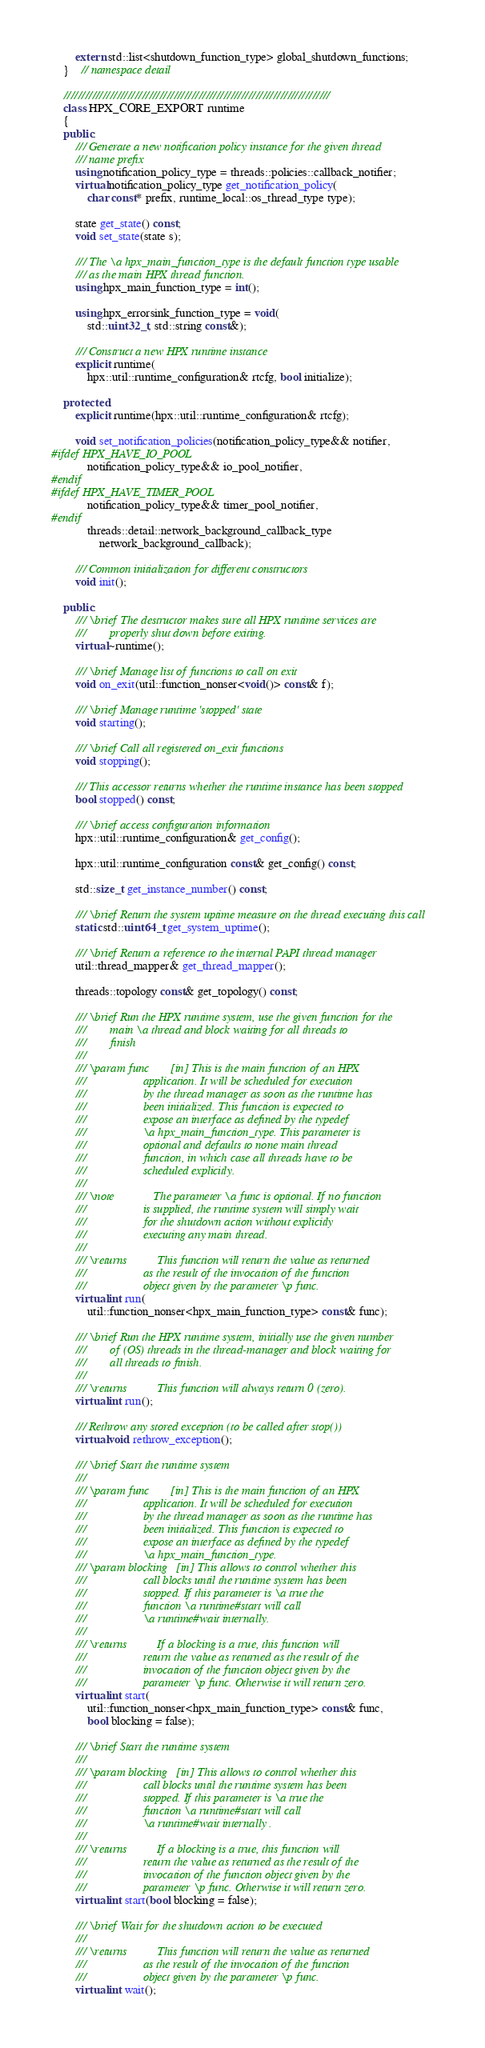Convert code to text. <code><loc_0><loc_0><loc_500><loc_500><_C++_>        extern std::list<shutdown_function_type> global_shutdown_functions;
    }    // namespace detail

    ///////////////////////////////////////////////////////////////////////////
    class HPX_CORE_EXPORT runtime
    {
    public:
        /// Generate a new notification policy instance for the given thread
        /// name prefix
        using notification_policy_type = threads::policies::callback_notifier;
        virtual notification_policy_type get_notification_policy(
            char const* prefix, runtime_local::os_thread_type type);

        state get_state() const;
        void set_state(state s);

        /// The \a hpx_main_function_type is the default function type usable
        /// as the main HPX thread function.
        using hpx_main_function_type = int();

        using hpx_errorsink_function_type = void(
            std::uint32_t, std::string const&);

        /// Construct a new HPX runtime instance
        explicit runtime(
            hpx::util::runtime_configuration& rtcfg, bool initialize);

    protected:
        explicit runtime(hpx::util::runtime_configuration& rtcfg);

        void set_notification_policies(notification_policy_type&& notifier,
#ifdef HPX_HAVE_IO_POOL
            notification_policy_type&& io_pool_notifier,
#endif
#ifdef HPX_HAVE_TIMER_POOL
            notification_policy_type&& timer_pool_notifier,
#endif
            threads::detail::network_background_callback_type
                network_background_callback);

        /// Common initialization for different constructors
        void init();

    public:
        /// \brief The destructor makes sure all HPX runtime services are
        ///        properly shut down before exiting.
        virtual ~runtime();

        /// \brief Manage list of functions to call on exit
        void on_exit(util::function_nonser<void()> const& f);

        /// \brief Manage runtime 'stopped' state
        void starting();

        /// \brief Call all registered on_exit functions
        void stopping();

        /// This accessor returns whether the runtime instance has been stopped
        bool stopped() const;

        /// \brief access configuration information
        hpx::util::runtime_configuration& get_config();

        hpx::util::runtime_configuration const& get_config() const;

        std::size_t get_instance_number() const;

        /// \brief Return the system uptime measure on the thread executing this call
        static std::uint64_t get_system_uptime();

        /// \brief Return a reference to the internal PAPI thread manager
        util::thread_mapper& get_thread_mapper();

        threads::topology const& get_topology() const;

        /// \brief Run the HPX runtime system, use the given function for the
        ///        main \a thread and block waiting for all threads to
        ///        finish
        ///
        /// \param func       [in] This is the main function of an HPX
        ///                   application. It will be scheduled for execution
        ///                   by the thread manager as soon as the runtime has
        ///                   been initialized. This function is expected to
        ///                   expose an interface as defined by the typedef
        ///                   \a hpx_main_function_type. This parameter is
        ///                   optional and defaults to none main thread
        ///                   function, in which case all threads have to be
        ///                   scheduled explicitly.
        ///
        /// \note             The parameter \a func is optional. If no function
        ///                   is supplied, the runtime system will simply wait
        ///                   for the shutdown action without explicitly
        ///                   executing any main thread.
        ///
        /// \returns          This function will return the value as returned
        ///                   as the result of the invocation of the function
        ///                   object given by the parameter \p func.
        virtual int run(
            util::function_nonser<hpx_main_function_type> const& func);

        /// \brief Run the HPX runtime system, initially use the given number
        ///        of (OS) threads in the thread-manager and block waiting for
        ///        all threads to finish.
        ///
        /// \returns          This function will always return 0 (zero).
        virtual int run();

        /// Rethrow any stored exception (to be called after stop())
        virtual void rethrow_exception();

        /// \brief Start the runtime system
        ///
        /// \param func       [in] This is the main function of an HPX
        ///                   application. It will be scheduled for execution
        ///                   by the thread manager as soon as the runtime has
        ///                   been initialized. This function is expected to
        ///                   expose an interface as defined by the typedef
        ///                   \a hpx_main_function_type.
        /// \param blocking   [in] This allows to control whether this
        ///                   call blocks until the runtime system has been
        ///                   stopped. If this parameter is \a true the
        ///                   function \a runtime#start will call
        ///                   \a runtime#wait internally.
        ///
        /// \returns          If a blocking is a true, this function will
        ///                   return the value as returned as the result of the
        ///                   invocation of the function object given by the
        ///                   parameter \p func. Otherwise it will return zero.
        virtual int start(
            util::function_nonser<hpx_main_function_type> const& func,
            bool blocking = false);

        /// \brief Start the runtime system
        ///
        /// \param blocking   [in] This allows to control whether this
        ///                   call blocks until the runtime system has been
        ///                   stopped. If this parameter is \a true the
        ///                   function \a runtime#start will call
        ///                   \a runtime#wait internally .
        ///
        /// \returns          If a blocking is a true, this function will
        ///                   return the value as returned as the result of the
        ///                   invocation of the function object given by the
        ///                   parameter \p func. Otherwise it will return zero.
        virtual int start(bool blocking = false);

        /// \brief Wait for the shutdown action to be executed
        ///
        /// \returns          This function will return the value as returned
        ///                   as the result of the invocation of the function
        ///                   object given by the parameter \p func.
        virtual int wait();
</code> 